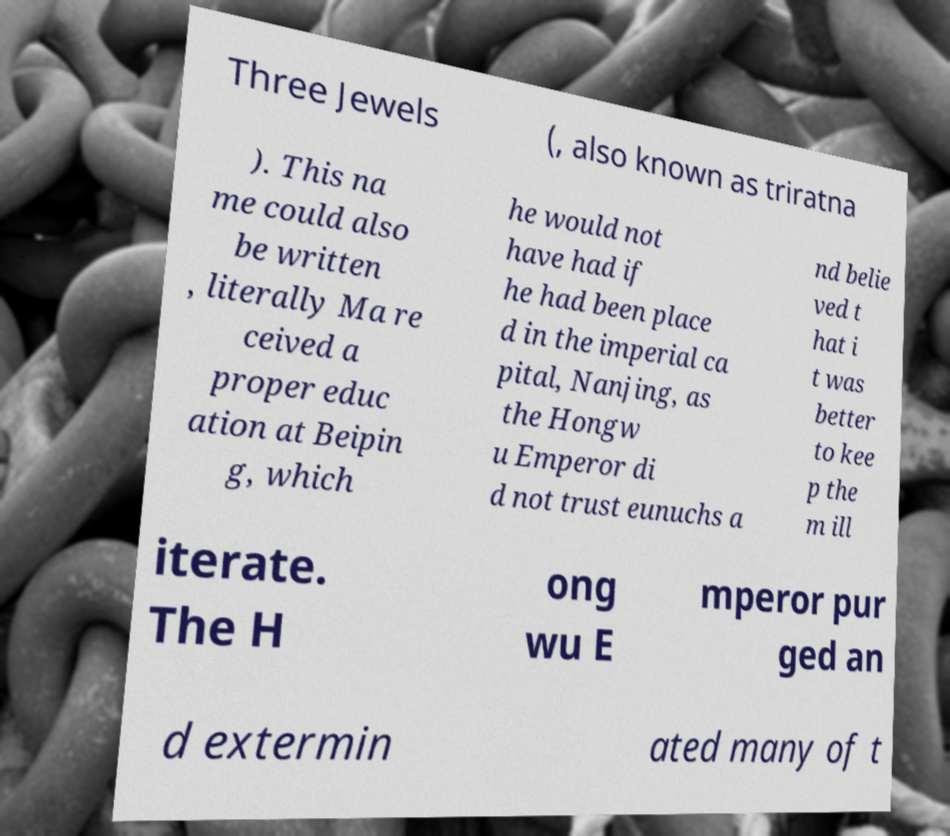What messages or text are displayed in this image? I need them in a readable, typed format. Three Jewels (, also known as triratna ). This na me could also be written , literally Ma re ceived a proper educ ation at Beipin g, which he would not have had if he had been place d in the imperial ca pital, Nanjing, as the Hongw u Emperor di d not trust eunuchs a nd belie ved t hat i t was better to kee p the m ill iterate. The H ong wu E mperor pur ged an d extermin ated many of t 